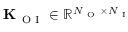Convert formula to latex. <formula><loc_0><loc_0><loc_500><loc_500>K _ { O I } \in \mathbb { R } ^ { N _ { O } \times N _ { I } }</formula> 